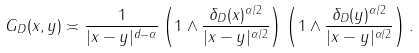Convert formula to latex. <formula><loc_0><loc_0><loc_500><loc_500>G _ { D } ( x , y ) \asymp \frac { 1 } { | x - y | ^ { d - \alpha } } \left ( 1 \wedge \frac { \delta _ { D } ( x ) ^ { \alpha / 2 } } { | x - y | ^ { \alpha / 2 } } \right ) \left ( 1 \wedge \frac { \delta _ { D } ( y ) ^ { \alpha / 2 } } { | x - y | ^ { \alpha / 2 } } \right ) .</formula> 